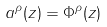<formula> <loc_0><loc_0><loc_500><loc_500>a ^ { \rho } ( z ) = \Phi ^ { \rho } ( z )</formula> 